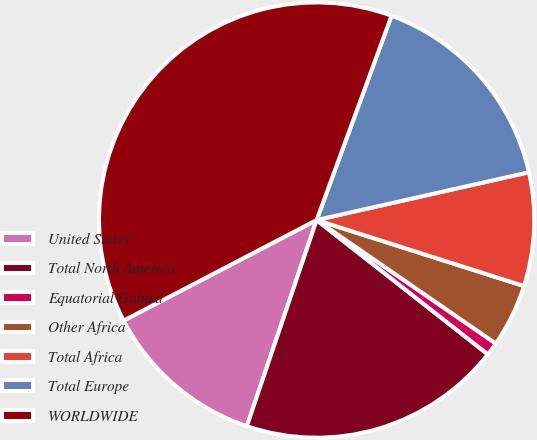Convert chart. <chart><loc_0><loc_0><loc_500><loc_500><pie_chart><fcel>United States<fcel>Total North America<fcel>Equatorial Guinea<fcel>Other Africa<fcel>Total Africa<fcel>Total Europe<fcel>WORLDWIDE<nl><fcel>12.16%<fcel>19.61%<fcel>0.98%<fcel>4.7%<fcel>8.43%<fcel>15.88%<fcel>38.24%<nl></chart> 